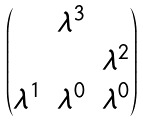Convert formula to latex. <formula><loc_0><loc_0><loc_500><loc_500>\begin{pmatrix} & \lambda ^ { 3 } & \\ & & \lambda ^ { 2 } \\ \lambda ^ { 1 } & \lambda ^ { 0 } & \lambda ^ { 0 } \end{pmatrix}</formula> 